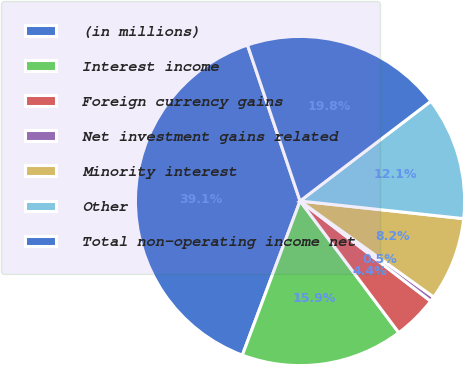<chart> <loc_0><loc_0><loc_500><loc_500><pie_chart><fcel>(in millions)<fcel>Interest income<fcel>Foreign currency gains<fcel>Net investment gains related<fcel>Minority interest<fcel>Other<fcel>Total non-operating income net<nl><fcel>39.12%<fcel>15.94%<fcel>4.35%<fcel>0.49%<fcel>8.21%<fcel>12.08%<fcel>19.8%<nl></chart> 